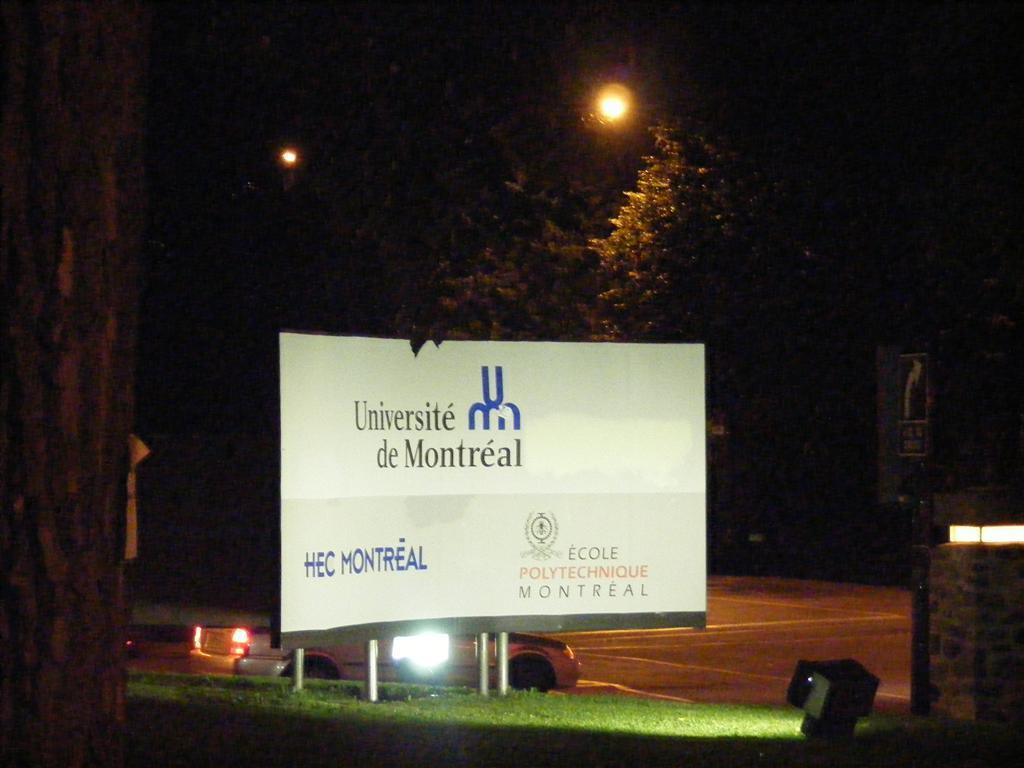<image>
Summarize the visual content of the image. Billboard for Universite de Montreal outdoors on a clear night. 